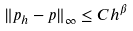Convert formula to latex. <formula><loc_0><loc_0><loc_500><loc_500>\| p _ { h } - p \| _ { \infty } \leq C h ^ { \beta }</formula> 